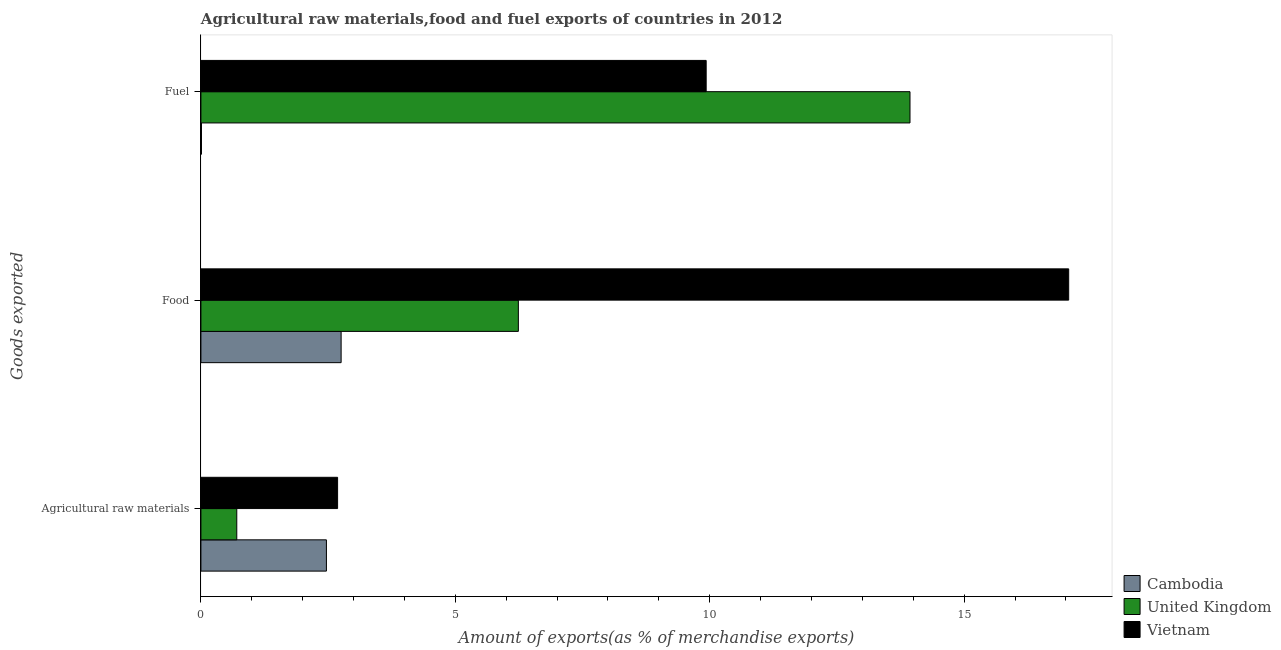How many groups of bars are there?
Offer a terse response. 3. What is the label of the 2nd group of bars from the top?
Make the answer very short. Food. What is the percentage of raw materials exports in Cambodia?
Ensure brevity in your answer.  2.47. Across all countries, what is the maximum percentage of raw materials exports?
Provide a short and direct response. 2.69. Across all countries, what is the minimum percentage of food exports?
Offer a terse response. 2.76. In which country was the percentage of food exports maximum?
Give a very brief answer. Vietnam. In which country was the percentage of raw materials exports minimum?
Provide a short and direct response. United Kingdom. What is the total percentage of raw materials exports in the graph?
Offer a terse response. 5.86. What is the difference between the percentage of raw materials exports in Cambodia and that in Vietnam?
Ensure brevity in your answer.  -0.22. What is the difference between the percentage of raw materials exports in United Kingdom and the percentage of fuel exports in Vietnam?
Ensure brevity in your answer.  -9.23. What is the average percentage of raw materials exports per country?
Your answer should be compact. 1.95. What is the difference between the percentage of food exports and percentage of fuel exports in Cambodia?
Make the answer very short. 2.74. What is the ratio of the percentage of fuel exports in United Kingdom to that in Vietnam?
Give a very brief answer. 1.4. Is the difference between the percentage of fuel exports in Cambodia and Vietnam greater than the difference between the percentage of raw materials exports in Cambodia and Vietnam?
Ensure brevity in your answer.  No. What is the difference between the highest and the second highest percentage of fuel exports?
Give a very brief answer. 4.01. What is the difference between the highest and the lowest percentage of food exports?
Your response must be concise. 14.3. In how many countries, is the percentage of fuel exports greater than the average percentage of fuel exports taken over all countries?
Provide a succinct answer. 2. Is the sum of the percentage of fuel exports in Vietnam and Cambodia greater than the maximum percentage of raw materials exports across all countries?
Ensure brevity in your answer.  Yes. What does the 1st bar from the top in Agricultural raw materials represents?
Your answer should be very brief. Vietnam. Is it the case that in every country, the sum of the percentage of raw materials exports and percentage of food exports is greater than the percentage of fuel exports?
Give a very brief answer. No. What is the difference between two consecutive major ticks on the X-axis?
Your answer should be very brief. 5. Where does the legend appear in the graph?
Offer a very short reply. Bottom right. How many legend labels are there?
Your answer should be very brief. 3. What is the title of the graph?
Keep it short and to the point. Agricultural raw materials,food and fuel exports of countries in 2012. What is the label or title of the X-axis?
Ensure brevity in your answer.  Amount of exports(as % of merchandise exports). What is the label or title of the Y-axis?
Offer a terse response. Goods exported. What is the Amount of exports(as % of merchandise exports) of Cambodia in Agricultural raw materials?
Offer a terse response. 2.47. What is the Amount of exports(as % of merchandise exports) of United Kingdom in Agricultural raw materials?
Offer a terse response. 0.7. What is the Amount of exports(as % of merchandise exports) of Vietnam in Agricultural raw materials?
Ensure brevity in your answer.  2.69. What is the Amount of exports(as % of merchandise exports) of Cambodia in Food?
Your answer should be compact. 2.76. What is the Amount of exports(as % of merchandise exports) in United Kingdom in Food?
Your answer should be compact. 6.24. What is the Amount of exports(as % of merchandise exports) in Vietnam in Food?
Your answer should be very brief. 17.05. What is the Amount of exports(as % of merchandise exports) in Cambodia in Fuel?
Your answer should be very brief. 0.01. What is the Amount of exports(as % of merchandise exports) of United Kingdom in Fuel?
Your answer should be compact. 13.94. What is the Amount of exports(as % of merchandise exports) of Vietnam in Fuel?
Give a very brief answer. 9.93. Across all Goods exported, what is the maximum Amount of exports(as % of merchandise exports) in Cambodia?
Give a very brief answer. 2.76. Across all Goods exported, what is the maximum Amount of exports(as % of merchandise exports) of United Kingdom?
Offer a terse response. 13.94. Across all Goods exported, what is the maximum Amount of exports(as % of merchandise exports) in Vietnam?
Your answer should be compact. 17.05. Across all Goods exported, what is the minimum Amount of exports(as % of merchandise exports) in Cambodia?
Give a very brief answer. 0.01. Across all Goods exported, what is the minimum Amount of exports(as % of merchandise exports) in United Kingdom?
Your answer should be compact. 0.7. Across all Goods exported, what is the minimum Amount of exports(as % of merchandise exports) of Vietnam?
Provide a short and direct response. 2.69. What is the total Amount of exports(as % of merchandise exports) of Cambodia in the graph?
Make the answer very short. 5.23. What is the total Amount of exports(as % of merchandise exports) of United Kingdom in the graph?
Offer a very short reply. 20.88. What is the total Amount of exports(as % of merchandise exports) in Vietnam in the graph?
Provide a short and direct response. 29.67. What is the difference between the Amount of exports(as % of merchandise exports) in Cambodia in Agricultural raw materials and that in Food?
Make the answer very short. -0.29. What is the difference between the Amount of exports(as % of merchandise exports) of United Kingdom in Agricultural raw materials and that in Food?
Ensure brevity in your answer.  -5.53. What is the difference between the Amount of exports(as % of merchandise exports) of Vietnam in Agricultural raw materials and that in Food?
Provide a succinct answer. -14.37. What is the difference between the Amount of exports(as % of merchandise exports) in Cambodia in Agricultural raw materials and that in Fuel?
Offer a terse response. 2.46. What is the difference between the Amount of exports(as % of merchandise exports) of United Kingdom in Agricultural raw materials and that in Fuel?
Provide a succinct answer. -13.23. What is the difference between the Amount of exports(as % of merchandise exports) in Vietnam in Agricultural raw materials and that in Fuel?
Your answer should be very brief. -7.24. What is the difference between the Amount of exports(as % of merchandise exports) of Cambodia in Food and that in Fuel?
Ensure brevity in your answer.  2.74. What is the difference between the Amount of exports(as % of merchandise exports) in United Kingdom in Food and that in Fuel?
Ensure brevity in your answer.  -7.7. What is the difference between the Amount of exports(as % of merchandise exports) in Vietnam in Food and that in Fuel?
Provide a succinct answer. 7.12. What is the difference between the Amount of exports(as % of merchandise exports) in Cambodia in Agricultural raw materials and the Amount of exports(as % of merchandise exports) in United Kingdom in Food?
Offer a terse response. -3.77. What is the difference between the Amount of exports(as % of merchandise exports) in Cambodia in Agricultural raw materials and the Amount of exports(as % of merchandise exports) in Vietnam in Food?
Make the answer very short. -14.59. What is the difference between the Amount of exports(as % of merchandise exports) in United Kingdom in Agricultural raw materials and the Amount of exports(as % of merchandise exports) in Vietnam in Food?
Make the answer very short. -16.35. What is the difference between the Amount of exports(as % of merchandise exports) of Cambodia in Agricultural raw materials and the Amount of exports(as % of merchandise exports) of United Kingdom in Fuel?
Provide a succinct answer. -11.47. What is the difference between the Amount of exports(as % of merchandise exports) of Cambodia in Agricultural raw materials and the Amount of exports(as % of merchandise exports) of Vietnam in Fuel?
Provide a short and direct response. -7.46. What is the difference between the Amount of exports(as % of merchandise exports) in United Kingdom in Agricultural raw materials and the Amount of exports(as % of merchandise exports) in Vietnam in Fuel?
Your answer should be compact. -9.23. What is the difference between the Amount of exports(as % of merchandise exports) of Cambodia in Food and the Amount of exports(as % of merchandise exports) of United Kingdom in Fuel?
Offer a terse response. -11.18. What is the difference between the Amount of exports(as % of merchandise exports) in Cambodia in Food and the Amount of exports(as % of merchandise exports) in Vietnam in Fuel?
Give a very brief answer. -7.17. What is the difference between the Amount of exports(as % of merchandise exports) of United Kingdom in Food and the Amount of exports(as % of merchandise exports) of Vietnam in Fuel?
Provide a short and direct response. -3.69. What is the average Amount of exports(as % of merchandise exports) of Cambodia per Goods exported?
Provide a succinct answer. 1.74. What is the average Amount of exports(as % of merchandise exports) of United Kingdom per Goods exported?
Give a very brief answer. 6.96. What is the average Amount of exports(as % of merchandise exports) of Vietnam per Goods exported?
Provide a succinct answer. 9.89. What is the difference between the Amount of exports(as % of merchandise exports) in Cambodia and Amount of exports(as % of merchandise exports) in United Kingdom in Agricultural raw materials?
Offer a very short reply. 1.76. What is the difference between the Amount of exports(as % of merchandise exports) in Cambodia and Amount of exports(as % of merchandise exports) in Vietnam in Agricultural raw materials?
Offer a very short reply. -0.22. What is the difference between the Amount of exports(as % of merchandise exports) of United Kingdom and Amount of exports(as % of merchandise exports) of Vietnam in Agricultural raw materials?
Your answer should be compact. -1.98. What is the difference between the Amount of exports(as % of merchandise exports) of Cambodia and Amount of exports(as % of merchandise exports) of United Kingdom in Food?
Offer a very short reply. -3.48. What is the difference between the Amount of exports(as % of merchandise exports) of Cambodia and Amount of exports(as % of merchandise exports) of Vietnam in Food?
Offer a very short reply. -14.3. What is the difference between the Amount of exports(as % of merchandise exports) of United Kingdom and Amount of exports(as % of merchandise exports) of Vietnam in Food?
Offer a very short reply. -10.82. What is the difference between the Amount of exports(as % of merchandise exports) in Cambodia and Amount of exports(as % of merchandise exports) in United Kingdom in Fuel?
Offer a very short reply. -13.92. What is the difference between the Amount of exports(as % of merchandise exports) in Cambodia and Amount of exports(as % of merchandise exports) in Vietnam in Fuel?
Your answer should be very brief. -9.92. What is the difference between the Amount of exports(as % of merchandise exports) of United Kingdom and Amount of exports(as % of merchandise exports) of Vietnam in Fuel?
Make the answer very short. 4.01. What is the ratio of the Amount of exports(as % of merchandise exports) in Cambodia in Agricultural raw materials to that in Food?
Keep it short and to the point. 0.9. What is the ratio of the Amount of exports(as % of merchandise exports) in United Kingdom in Agricultural raw materials to that in Food?
Offer a very short reply. 0.11. What is the ratio of the Amount of exports(as % of merchandise exports) of Vietnam in Agricultural raw materials to that in Food?
Offer a very short reply. 0.16. What is the ratio of the Amount of exports(as % of merchandise exports) of Cambodia in Agricultural raw materials to that in Fuel?
Your answer should be compact. 226.11. What is the ratio of the Amount of exports(as % of merchandise exports) in United Kingdom in Agricultural raw materials to that in Fuel?
Ensure brevity in your answer.  0.05. What is the ratio of the Amount of exports(as % of merchandise exports) of Vietnam in Agricultural raw materials to that in Fuel?
Give a very brief answer. 0.27. What is the ratio of the Amount of exports(as % of merchandise exports) of Cambodia in Food to that in Fuel?
Give a very brief answer. 252.61. What is the ratio of the Amount of exports(as % of merchandise exports) of United Kingdom in Food to that in Fuel?
Your answer should be very brief. 0.45. What is the ratio of the Amount of exports(as % of merchandise exports) in Vietnam in Food to that in Fuel?
Your answer should be very brief. 1.72. What is the difference between the highest and the second highest Amount of exports(as % of merchandise exports) in Cambodia?
Make the answer very short. 0.29. What is the difference between the highest and the second highest Amount of exports(as % of merchandise exports) of United Kingdom?
Your response must be concise. 7.7. What is the difference between the highest and the second highest Amount of exports(as % of merchandise exports) in Vietnam?
Keep it short and to the point. 7.12. What is the difference between the highest and the lowest Amount of exports(as % of merchandise exports) in Cambodia?
Your answer should be compact. 2.74. What is the difference between the highest and the lowest Amount of exports(as % of merchandise exports) of United Kingdom?
Give a very brief answer. 13.23. What is the difference between the highest and the lowest Amount of exports(as % of merchandise exports) in Vietnam?
Your answer should be very brief. 14.37. 